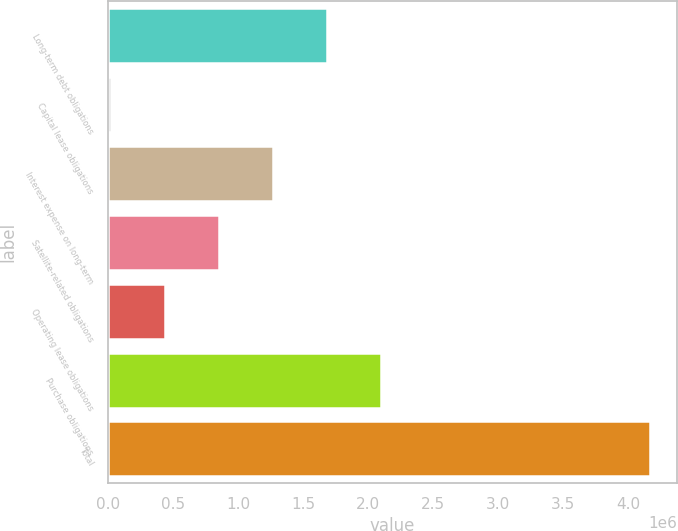Convert chart to OTSL. <chart><loc_0><loc_0><loc_500><loc_500><bar_chart><fcel>Long-term debt obligations<fcel>Capital lease obligations<fcel>Interest expense on long-term<fcel>Satellite-related obligations<fcel>Operating lease obligations<fcel>Purchase obligations<fcel>Total<nl><fcel>1.68229e+06<fcel>27042<fcel>1.26847e+06<fcel>854664<fcel>440853<fcel>2.0961e+06<fcel>4.16515e+06<nl></chart> 